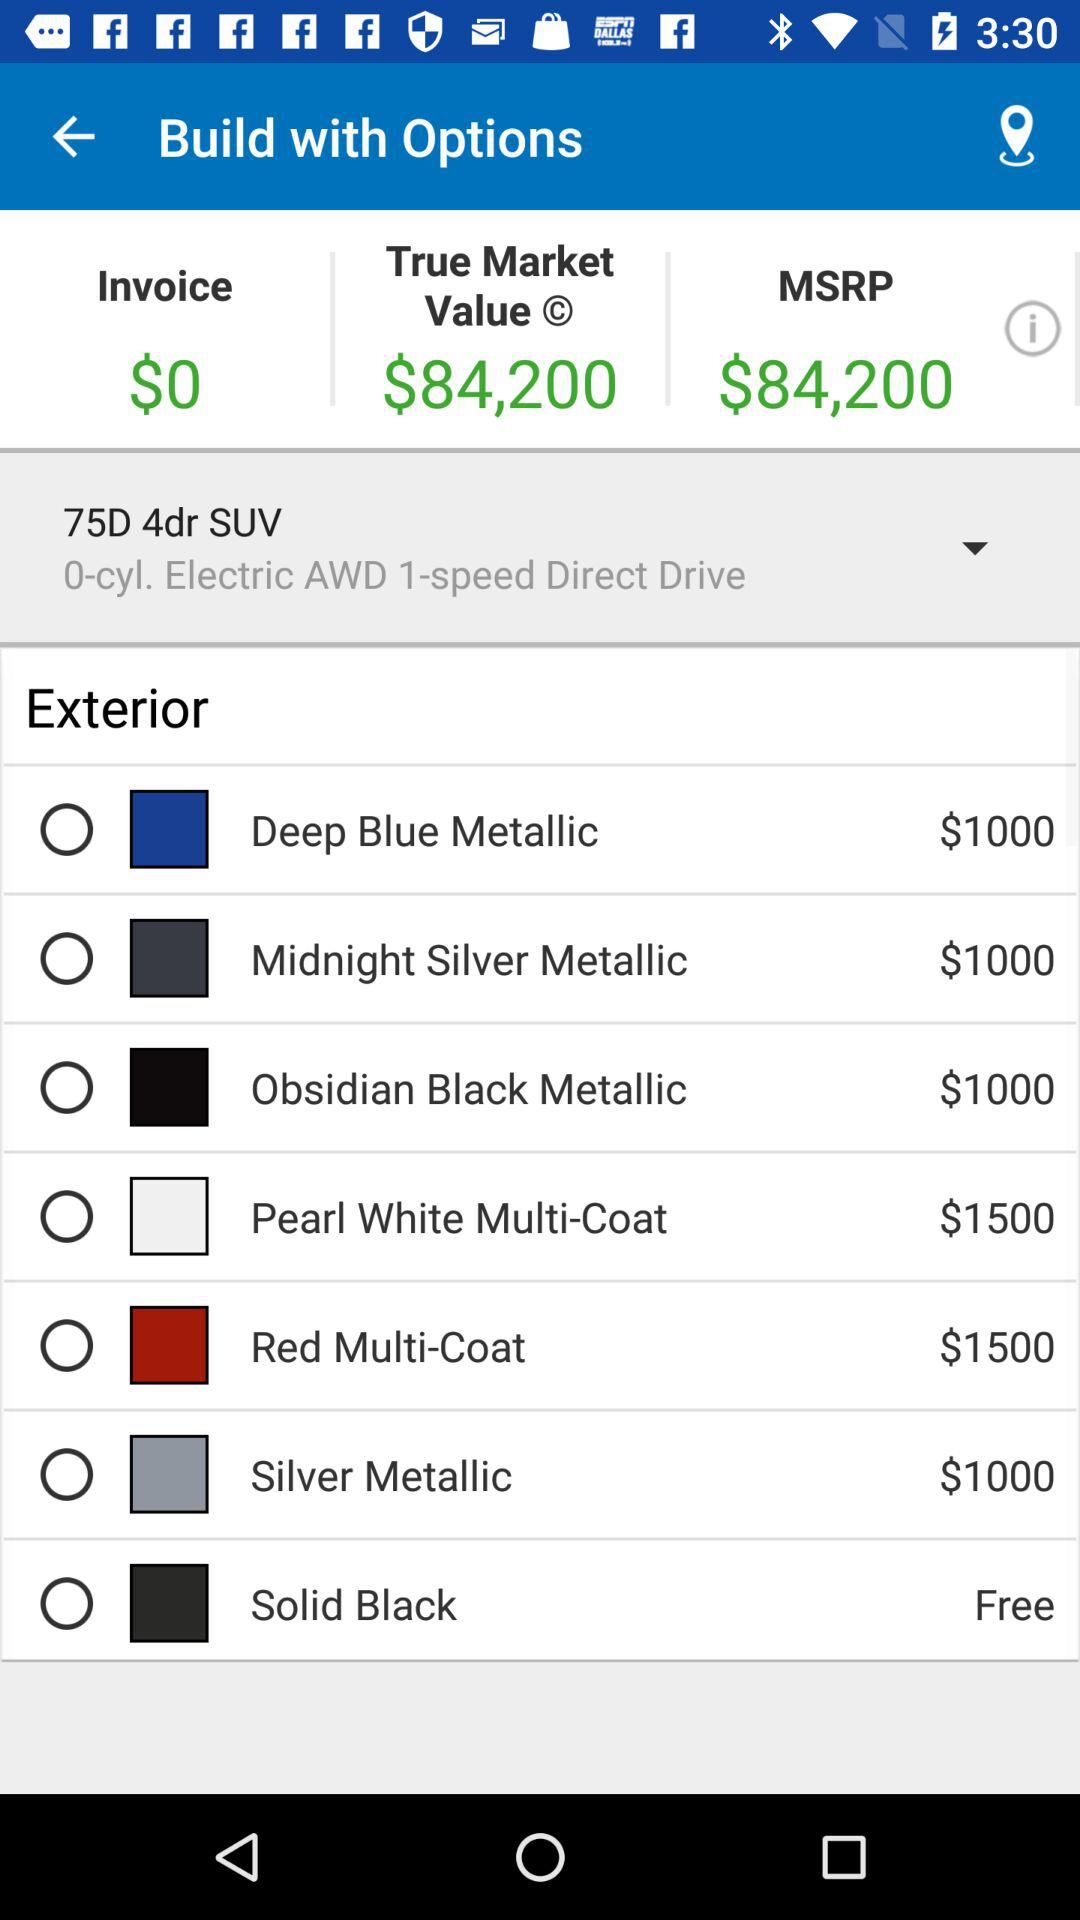Which exterior is free? The free exterior is solid black. 